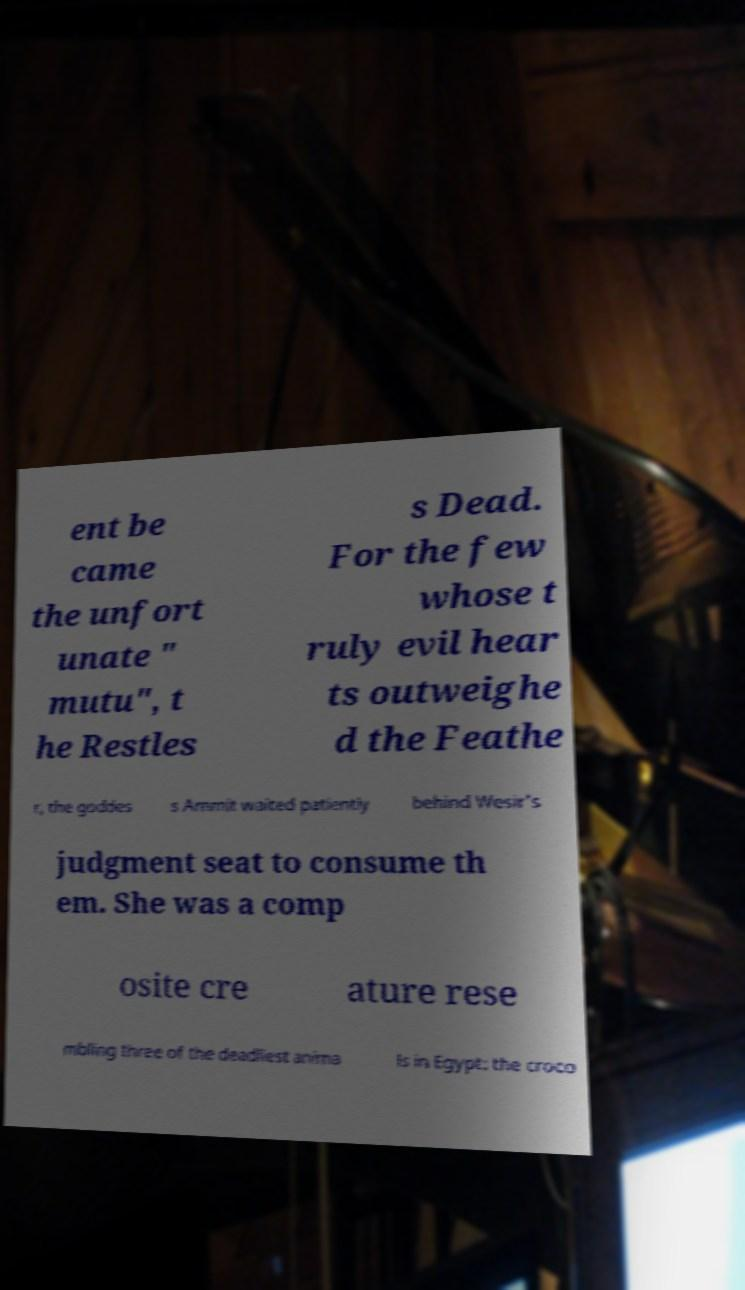Can you accurately transcribe the text from the provided image for me? ent be came the unfort unate " mutu", t he Restles s Dead. For the few whose t ruly evil hear ts outweighe d the Feathe r, the goddes s Ammit waited patiently behind Wesir's judgment seat to consume th em. She was a comp osite cre ature rese mbling three of the deadliest anima ls in Egypt: the croco 